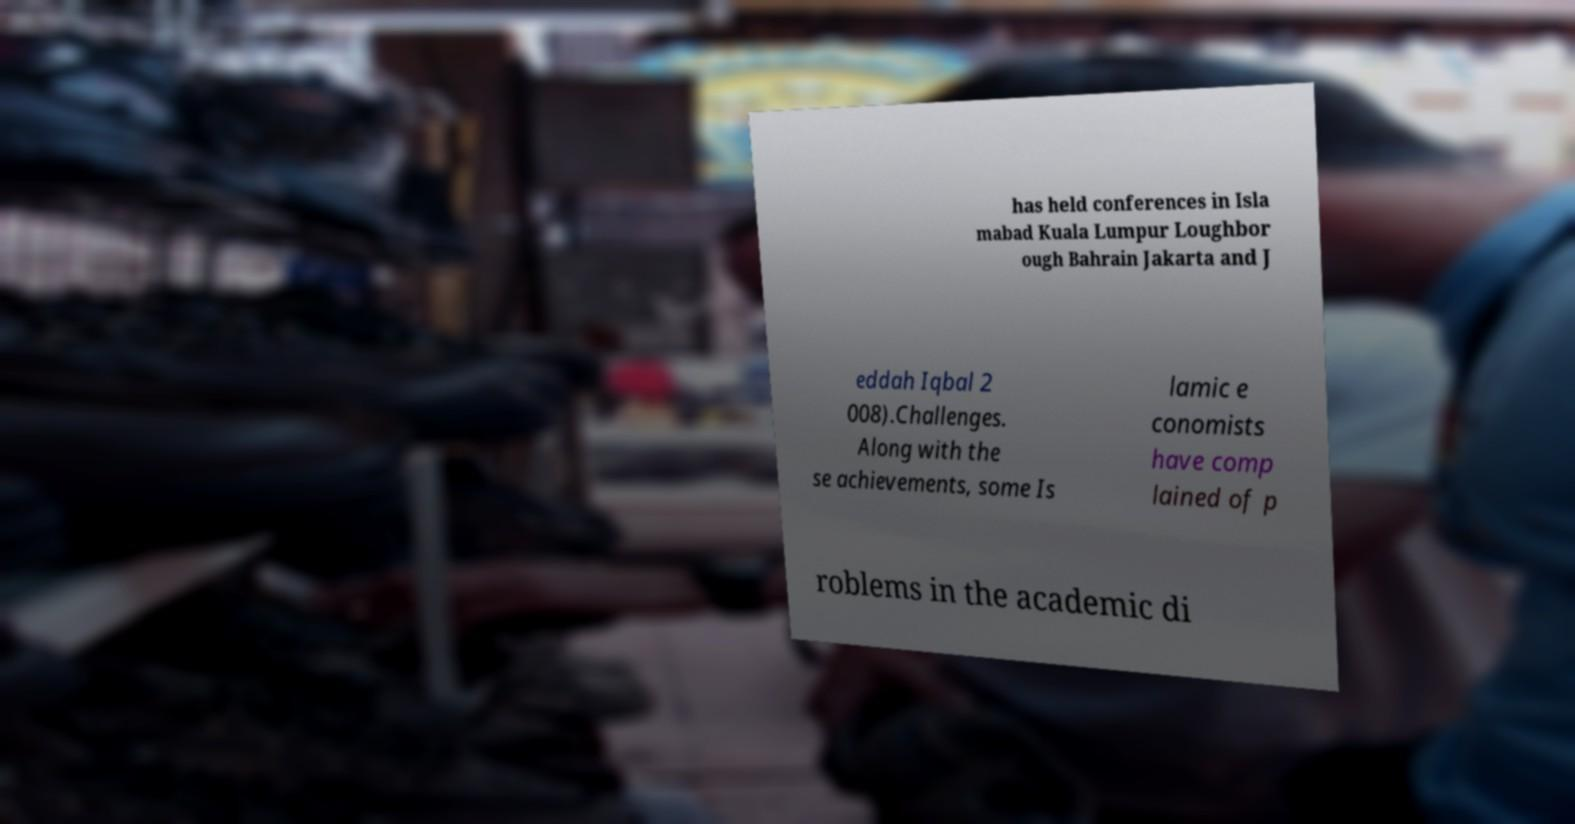Can you read and provide the text displayed in the image?This photo seems to have some interesting text. Can you extract and type it out for me? has held conferences in Isla mabad Kuala Lumpur Loughbor ough Bahrain Jakarta and J eddah Iqbal 2 008).Challenges. Along with the se achievements, some Is lamic e conomists have comp lained of p roblems in the academic di 